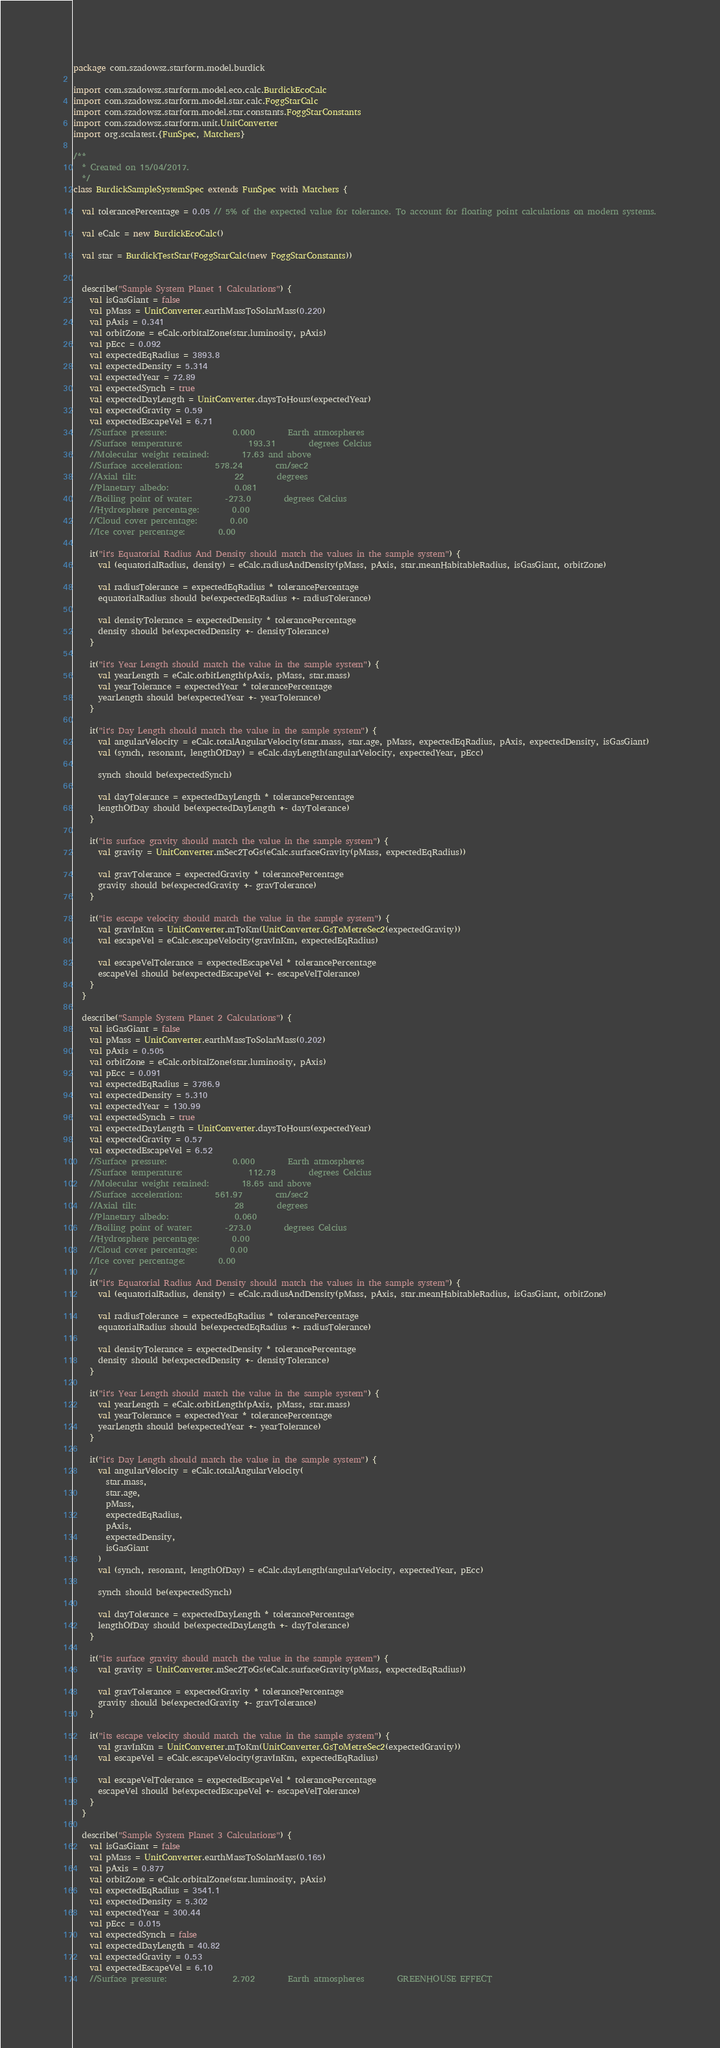<code> <loc_0><loc_0><loc_500><loc_500><_Scala_>package com.szadowsz.starform.model.burdick

import com.szadowsz.starform.model.eco.calc.BurdickEcoCalc
import com.szadowsz.starform.model.star.calc.FoggStarCalc
import com.szadowsz.starform.model.star.constants.FoggStarConstants
import com.szadowsz.starform.unit.UnitConverter
import org.scalatest.{FunSpec, Matchers}

/**
  * Created on 15/04/2017.
  */
class BurdickSampleSystemSpec extends FunSpec with Matchers {

  val tolerancePercentage = 0.05 // 5% of the expected value for tolerance. To account for floating point calculations on modern systems.

  val eCalc = new BurdickEcoCalc()

  val star = BurdickTestStar(FoggStarCalc(new FoggStarConstants))


  describe("Sample System Planet 1 Calculations") {
    val isGasGiant = false
    val pMass = UnitConverter.earthMassToSolarMass(0.220)
    val pAxis = 0.341
    val orbitZone = eCalc.orbitalZone(star.luminosity, pAxis)
    val pEcc = 0.092
    val expectedEqRadius = 3893.8
    val expectedDensity = 5.314
    val expectedYear = 72.89
    val expectedSynch = true
    val expectedDayLength = UnitConverter.daysToHours(expectedYear)
    val expectedGravity = 0.59
    val expectedEscapeVel = 6.71
    //Surface pressure:                0.000        Earth atmospheres
    //Surface temperature:                193.31        degrees Celcius
    //Molecular weight retained:        17.63 and above
    //Surface acceleration:        578.24        cm/sec2
    //Axial tilt:                        22        degrees
    //Planetary albedo:                0.081
    //Boiling point of water:        -273.0        degrees Celcius
    //Hydrosphere percentage:        0.00
    //Cloud cover percentage:        0.00
    //Ice cover percentage:        0.00

    it("it's Equatorial Radius And Density should match the values in the sample system") {
      val (equatorialRadius, density) = eCalc.radiusAndDensity(pMass, pAxis, star.meanHabitableRadius, isGasGiant, orbitZone)

      val radiusTolerance = expectedEqRadius * tolerancePercentage
      equatorialRadius should be(expectedEqRadius +- radiusTolerance)

      val densityTolerance = expectedDensity * tolerancePercentage
      density should be(expectedDensity +- densityTolerance)
    }

    it("it's Year Length should match the value in the sample system") {
      val yearLength = eCalc.orbitLength(pAxis, pMass, star.mass)
      val yearTolerance = expectedYear * tolerancePercentage
      yearLength should be(expectedYear +- yearTolerance)
    }

    it("it's Day Length should match the value in the sample system") {
      val angularVelocity = eCalc.totalAngularVelocity(star.mass, star.age, pMass, expectedEqRadius, pAxis, expectedDensity, isGasGiant)
      val (synch, resonant, lengthOfDay) = eCalc.dayLength(angularVelocity, expectedYear, pEcc)

      synch should be(expectedSynch)

      val dayTolerance = expectedDayLength * tolerancePercentage
      lengthOfDay should be(expectedDayLength +- dayTolerance)
    }

    it("its surface gravity should match the value in the sample system") {
      val gravity = UnitConverter.mSec2ToGs(eCalc.surfaceGravity(pMass, expectedEqRadius))

      val gravTolerance = expectedGravity * tolerancePercentage
      gravity should be(expectedGravity +- gravTolerance)
    }

    it("its escape velocity should match the value in the sample system") {
      val gravInKm = UnitConverter.mToKm(UnitConverter.GsToMetreSec2(expectedGravity))
      val escapeVel = eCalc.escapeVelocity(gravInKm, expectedEqRadius)

      val escapeVelTolerance = expectedEscapeVel * tolerancePercentage
      escapeVel should be(expectedEscapeVel +- escapeVelTolerance)
    }
  }

  describe("Sample System Planet 2 Calculations") {
    val isGasGiant = false
    val pMass = UnitConverter.earthMassToSolarMass(0.202)
    val pAxis = 0.505
    val orbitZone = eCalc.orbitalZone(star.luminosity, pAxis)
    val pEcc = 0.091
    val expectedEqRadius = 3786.9
    val expectedDensity = 5.310
    val expectedYear = 130.99
    val expectedSynch = true
    val expectedDayLength = UnitConverter.daysToHours(expectedYear)
    val expectedGravity = 0.57
    val expectedEscapeVel = 6.52
    //Surface pressure:                0.000        Earth atmospheres
    //Surface temperature:                112.78        degrees Celcius
    //Molecular weight retained:        18.65 and above
    //Surface acceleration:        561.97        cm/sec2
    //Axial tilt:                        28        degrees
    //Planetary albedo:                0.060
    //Boiling point of water:        -273.0        degrees Celcius
    //Hydrosphere percentage:        0.00
    //Cloud cover percentage:        0.00
    //Ice cover percentage:        0.00
    //
    it("it's Equatorial Radius And Density should match the values in the sample system") {
      val (equatorialRadius, density) = eCalc.radiusAndDensity(pMass, pAxis, star.meanHabitableRadius, isGasGiant, orbitZone)

      val radiusTolerance = expectedEqRadius * tolerancePercentage
      equatorialRadius should be(expectedEqRadius +- radiusTolerance)

      val densityTolerance = expectedDensity * tolerancePercentage
      density should be(expectedDensity +- densityTolerance)
    }

    it("it's Year Length should match the value in the sample system") {
      val yearLength = eCalc.orbitLength(pAxis, pMass, star.mass)
      val yearTolerance = expectedYear * tolerancePercentage
      yearLength should be(expectedYear +- yearTolerance)
    }

    it("it's Day Length should match the value in the sample system") {
      val angularVelocity = eCalc.totalAngularVelocity(
        star.mass,
        star.age,
        pMass,
        expectedEqRadius,
        pAxis,
        expectedDensity,
        isGasGiant
      )
      val (synch, resonant, lengthOfDay) = eCalc.dayLength(angularVelocity, expectedYear, pEcc)

      synch should be(expectedSynch)

      val dayTolerance = expectedDayLength * tolerancePercentage
      lengthOfDay should be(expectedDayLength +- dayTolerance)
    }

    it("its surface gravity should match the value in the sample system") {
      val gravity = UnitConverter.mSec2ToGs(eCalc.surfaceGravity(pMass, expectedEqRadius))

      val gravTolerance = expectedGravity * tolerancePercentage
      gravity should be(expectedGravity +- gravTolerance)
    }

    it("its escape velocity should match the value in the sample system") {
      val gravInKm = UnitConverter.mToKm(UnitConverter.GsToMetreSec2(expectedGravity))
      val escapeVel = eCalc.escapeVelocity(gravInKm, expectedEqRadius)

      val escapeVelTolerance = expectedEscapeVel * tolerancePercentage
      escapeVel should be(expectedEscapeVel +- escapeVelTolerance)
    }
  }

  describe("Sample System Planet 3 Calculations") {
    val isGasGiant = false
    val pMass = UnitConverter.earthMassToSolarMass(0.165)
    val pAxis = 0.877
    val orbitZone = eCalc.orbitalZone(star.luminosity, pAxis)
    val expectedEqRadius = 3541.1
    val expectedDensity = 5.302
    val expectedYear = 300.44
    val pEcc = 0.015
    val expectedSynch = false
    val expectedDayLength = 40.82
    val expectedGravity = 0.53
    val expectedEscapeVel = 6.10
    //Surface pressure:                2.702        Earth atmospheres        GREENHOUSE EFFECT</code> 